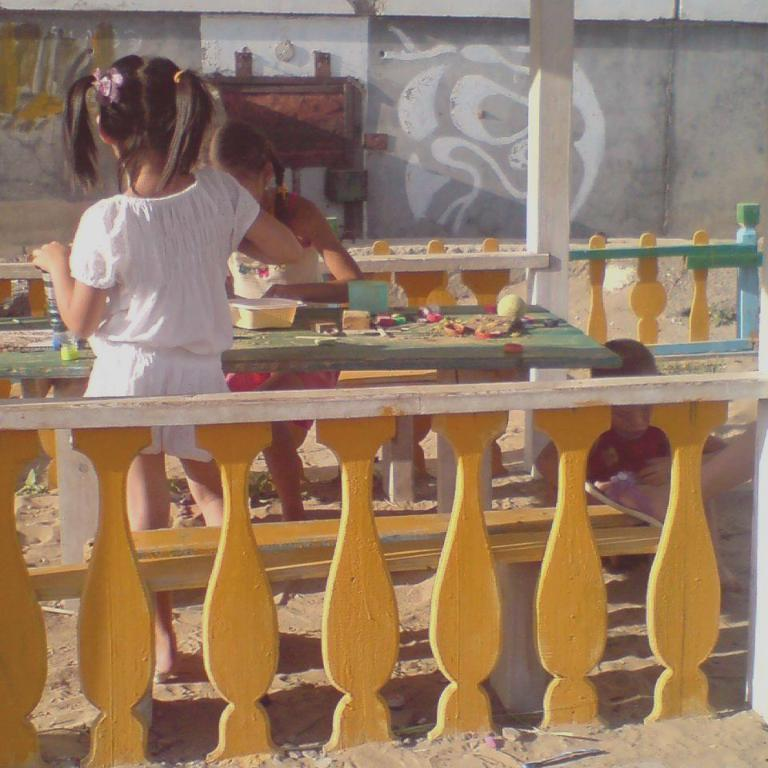How many girls are in the image? There are two girls in the image. What are the positions of the girls in the image? One girl is sitting, and the other is standing. What object can be seen on a table in the image? There is a box on a table in the image. What type of game is the zebra playing with the girls in the image? There is no zebra present in the image, so it is not possible to determine what game, if any, might be played with the girls. 